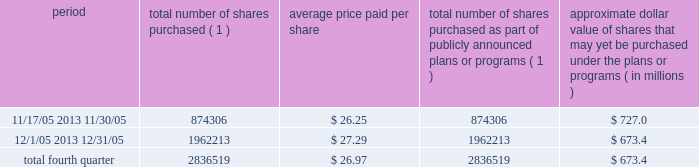Discussion and analysis of financial condition and results of operations 2014liquidity and capital resources 2014 factors affecting sources of liquidity . 201d recent sales of unregistered securities during the year ended december 31 , 2005 , we issued an aggregate of 4670335 shares of our class a common stock upon conversion of $ 57.1 million principal amount of our 3.25% ( 3.25 % ) notes .
Pursuant to the terms of the indenture , the holders of the 3.25% ( 3.25 % ) notes received 81.808 shares of class a common stock for every $ 1000 principal amount of notes converted .
The shares were issued to the noteholders in reliance on the exemption from registration set forth in section 3 ( a ) ( 9 ) of the securities act of 1933 , as amended .
No underwriters were engaged in connection with such issuances .
In connection with the conversion , we paid such holders an aggregate of $ 4.9 million , calculated based on the accrued and unpaid interest on the notes and the discounted value of the future interest payments on the notes .
Subsequent to december 31 , 2005 , we issued shares of class a common stock upon conversions of additional 3.25% ( 3.25 % ) notes , as set forth in item 9b of this annual report under the caption 201cother information . 201d during the year ended december 31 , 2005 , we issued an aggregate of 398412 shares of our class a common stock upon exercises of 55729 warrants assumed in our merger with spectrasite , inc .
In august 2005 , in connection with our merger with spectrasite , inc. , we assumed approximately 1.0 million warrants to purchase shares of spectrasite , inc .
Common stock .
Upon completion of the merger , each warrant to purchase shares of spectrasite , inc .
Common stock automatically converted into a warrant to purchase 7.15 shares of class a common stock at an exercise price of $ 32 per warrant .
Net proceeds from these warrant exercises were approximately $ 1.8 million .
The shares of class a common stock issued to the warrantholders upon exercise of the warrants were issued in reliance on the exemption from registration set forth in section 3 ( a ) ( 9 ) of the securities act of 1933 , as amended .
No underwriters were engaged in connection with such issuances .
Subsequent to december 31 , 2005 , we issued shares of class a common stock upon exercises of additional warrants , as set forth in item 9b of this annual report under the caption 201cother information . 201d issuer purchases of equity securities in november 2005 , we announced that our board of directors had approved a stock repurchase program pursuant to which we intend to repurchase up to $ 750.0 million of our class a common stock through december 2006 .
During the fourth quarter of 2005 , we repurchased 2836519 shares of our class a common stock for an aggregate of $ 76.6 million pursuant to our stock repurchase program , as follows : period total number of shares purchased ( 1 ) average price paid per share total number of shares purchased as part of publicly announced plans or programs ( 1 ) approximate dollar value of shares that may yet be purchased under the plans or programs ( in millions ) .
( 1 ) all issuer repurchases were made pursuant to the stock repurchase program publicly announced in november 2005 .
Pursuant to the program , we intend to repurchase up to $ 750.0 million of our class a common stock during the period november 2005 through december 2006 .
Under the program , our management is authorized to purchase shares from time to time in open market purchases or privately negotiated transactions at prevailing prices as permitted by securities laws and other legal requirements , and subject to market conditions and other factors .
To facilitate repurchases , we entered into a trading plan under rule 10b5-1 of the securities exchange act of 1934 , which allows us to repurchase shares during periods when we otherwise might be prevented from doing so under insider trading laws or because of self- imposed trading blackout periods .
The program may be discontinued at any time .
Since december 31 , 2005 , we have continued to repurchase shares of our class a common stock pursuant to our stock repurchase program .
Between january 1 , 2006 and march 9 , 2006 , we repurchased 3.9 million shares of class a common stock for an aggregate of $ 117.4 million pursuant to the stock repurchase program. .
What is the total amount of cash used for stock repurchase during december 2005 , in millions? 
Computations: ((1962213 * 27.29) / 1000000)
Answer: 53.54879. 